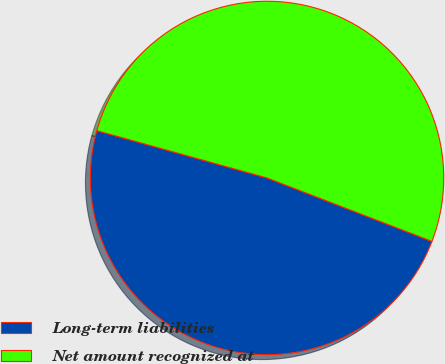Convert chart. <chart><loc_0><loc_0><loc_500><loc_500><pie_chart><fcel>Long-term liabilities<fcel>Net amount recognized at<nl><fcel>48.47%<fcel>51.53%<nl></chart> 